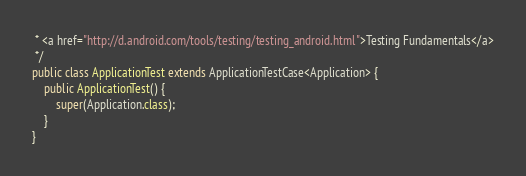<code> <loc_0><loc_0><loc_500><loc_500><_Java_> * <a href="http://d.android.com/tools/testing/testing_android.html">Testing Fundamentals</a>
 */
public class ApplicationTest extends ApplicationTestCase<Application> {
    public ApplicationTest() {
        super(Application.class);
    }
}</code> 